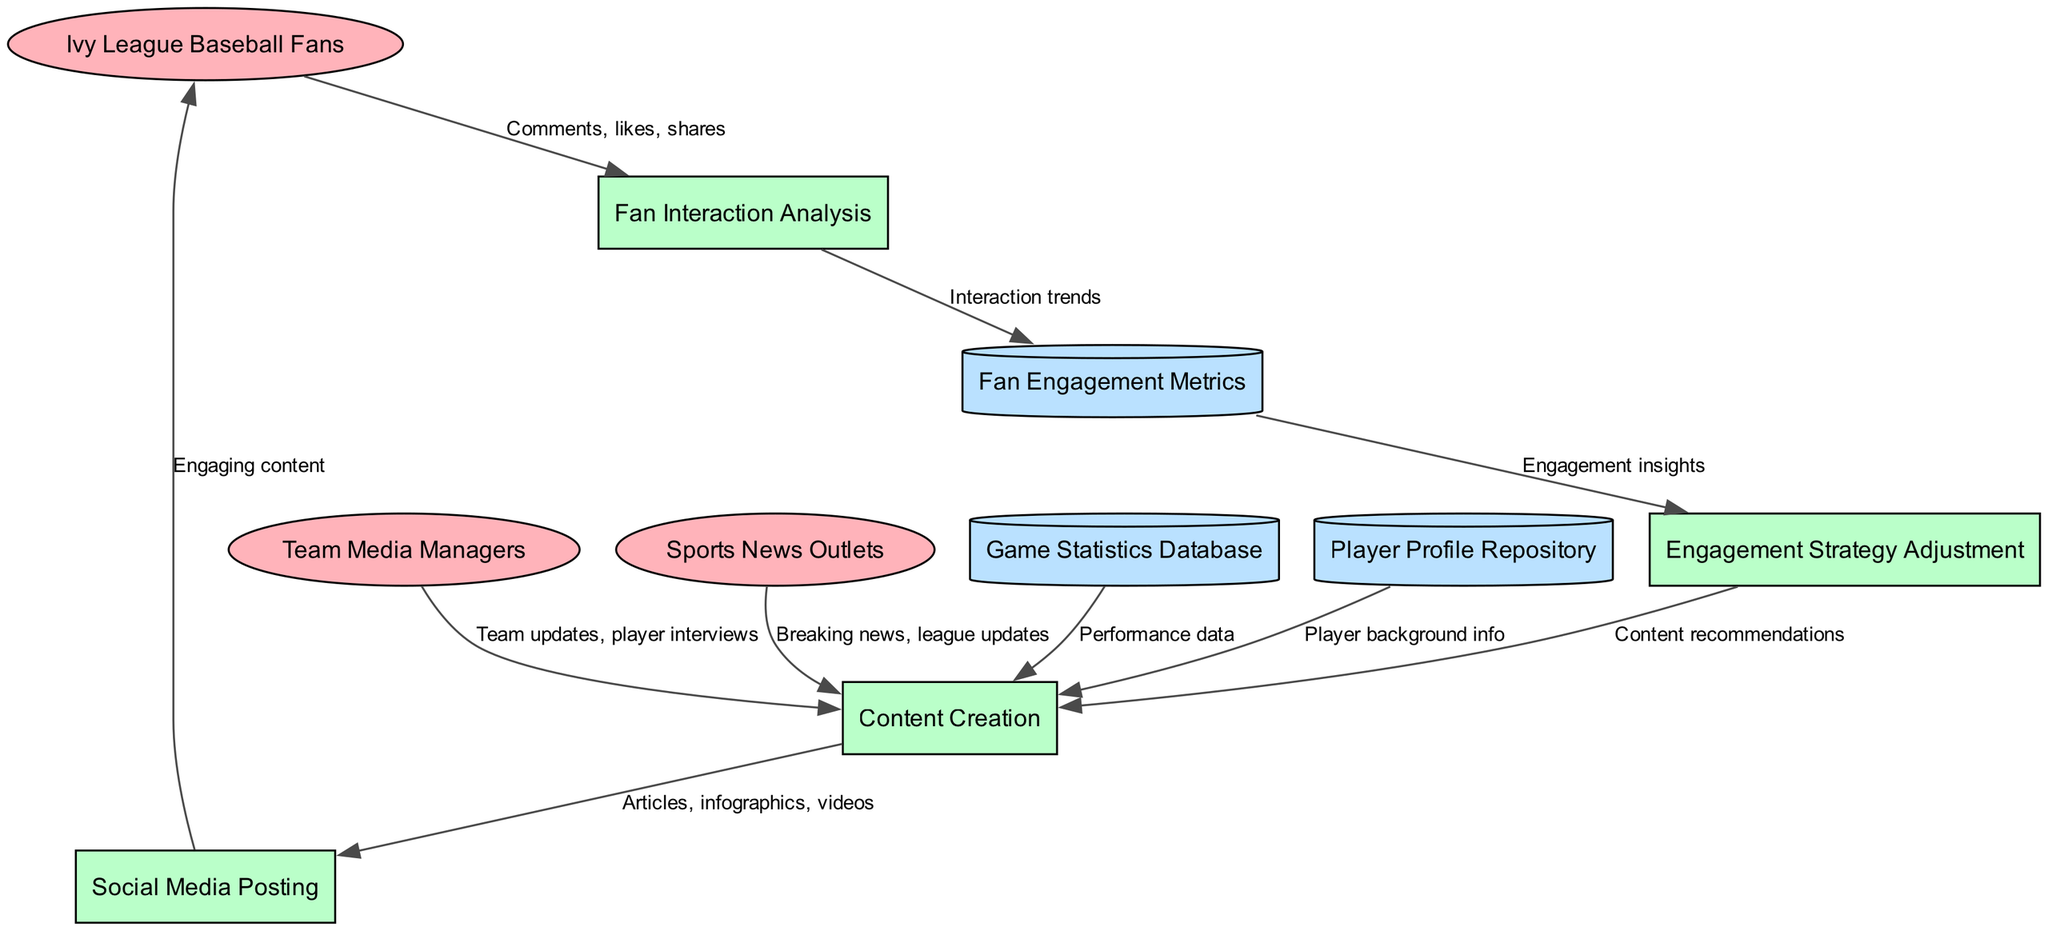What are the external entities involved in the process? The external entities, which are represented in ellipses and consist of Ivy League Baseball Fans, Team Media Managers, and Sports News Outlets, are listed at the top of the diagram.
Answer: Ivy League Baseball Fans, Team Media Managers, Sports News Outlets How many processes are depicted in the diagram? The processes are represented within rectangles in the diagram. Counting them, we find there are four processes: Content Creation, Social Media Posting, Fan Interaction Analysis, and Engagement Strategy Adjustment.
Answer: Four Which process receives comments, likes, and shares? The flow of "Comments, likes, shares" originates from the external entity Ivy League Baseball Fans and points to the process Fan Interaction Analysis, indicating that this process receives those inputs.
Answer: Fan Interaction Analysis What is the source of performance data? The performance data is sourced from the Game Statistics Database, which flows into the Content Creation process as indicated in the diagram.
Answer: Game Statistics Database Which data store provides engagement insights? The Fan Engagement Metrics data store provides engagement insights, which is indicated by the flow from Fan Interaction Analysis to Fan Engagement Metrics, and then from there to Engagement Strategy Adjustment.
Answer: Fan Engagement Metrics What content is posted on social media? The Social Media Posting process receives Articles, infographics, and videos from the Content Creation process, which indicates the types of content being posted on social media.
Answer: Articles, infographics, videos How does engagement strategy adjustment influence content creation? The Engagement Strategy Adjustment process provides "Content recommendations" back to the Content Creation process, signifying this influence. The flow direction can be traced in the diagram to understand this interaction.
Answer: Content recommendations Which external entity provides breaking news and league updates? The flow indicates that Sports News Outlets supply breaking news and league updates which feed into the Content Creation process, highlighting their role in content generation.
Answer: Sports News Outlets What type of analysis is conducted in the process concerning fan interactions? The process identified as Fan Interaction Analysis centers on studying fan interactions, as evidenced by the connection to comments, likes, and shares that serve as its input.
Answer: Analysis of fan interactions 